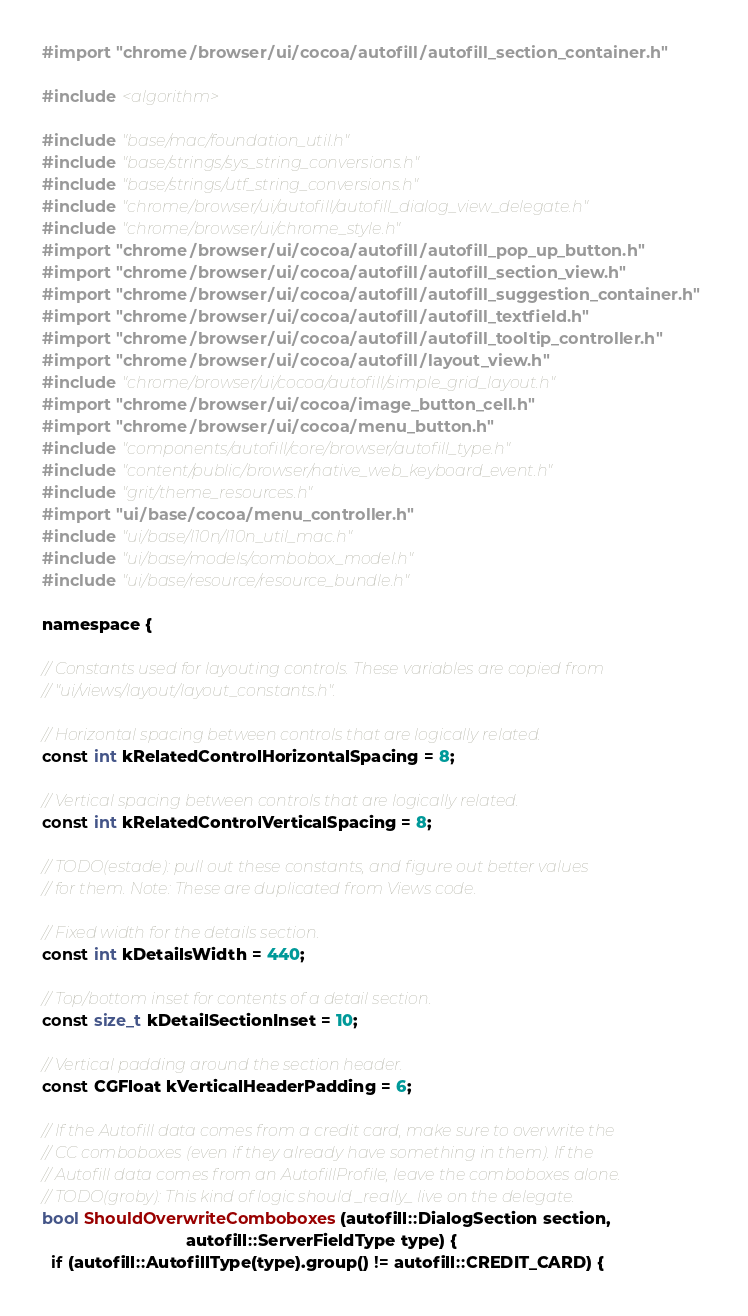Convert code to text. <code><loc_0><loc_0><loc_500><loc_500><_ObjectiveC_>#import "chrome/browser/ui/cocoa/autofill/autofill_section_container.h"

#include <algorithm>

#include "base/mac/foundation_util.h"
#include "base/strings/sys_string_conversions.h"
#include "base/strings/utf_string_conversions.h"
#include "chrome/browser/ui/autofill/autofill_dialog_view_delegate.h"
#include "chrome/browser/ui/chrome_style.h"
#import "chrome/browser/ui/cocoa/autofill/autofill_pop_up_button.h"
#import "chrome/browser/ui/cocoa/autofill/autofill_section_view.h"
#import "chrome/browser/ui/cocoa/autofill/autofill_suggestion_container.h"
#import "chrome/browser/ui/cocoa/autofill/autofill_textfield.h"
#import "chrome/browser/ui/cocoa/autofill/autofill_tooltip_controller.h"
#import "chrome/browser/ui/cocoa/autofill/layout_view.h"
#include "chrome/browser/ui/cocoa/autofill/simple_grid_layout.h"
#import "chrome/browser/ui/cocoa/image_button_cell.h"
#import "chrome/browser/ui/cocoa/menu_button.h"
#include "components/autofill/core/browser/autofill_type.h"
#include "content/public/browser/native_web_keyboard_event.h"
#include "grit/theme_resources.h"
#import "ui/base/cocoa/menu_controller.h"
#include "ui/base/l10n/l10n_util_mac.h"
#include "ui/base/models/combobox_model.h"
#include "ui/base/resource/resource_bundle.h"

namespace {

// Constants used for layouting controls. These variables are copied from
// "ui/views/layout/layout_constants.h".

// Horizontal spacing between controls that are logically related.
const int kRelatedControlHorizontalSpacing = 8;

// Vertical spacing between controls that are logically related.
const int kRelatedControlVerticalSpacing = 8;

// TODO(estade): pull out these constants, and figure out better values
// for them. Note: These are duplicated from Views code.

// Fixed width for the details section.
const int kDetailsWidth = 440;

// Top/bottom inset for contents of a detail section.
const size_t kDetailSectionInset = 10;

// Vertical padding around the section header.
const CGFloat kVerticalHeaderPadding = 6;

// If the Autofill data comes from a credit card, make sure to overwrite the
// CC comboboxes (even if they already have something in them). If the
// Autofill data comes from an AutofillProfile, leave the comboboxes alone.
// TODO(groby): This kind of logic should _really_ live on the delegate.
bool ShouldOverwriteComboboxes(autofill::DialogSection section,
                               autofill::ServerFieldType type) {
  if (autofill::AutofillType(type).group() != autofill::CREDIT_CARD) {</code> 